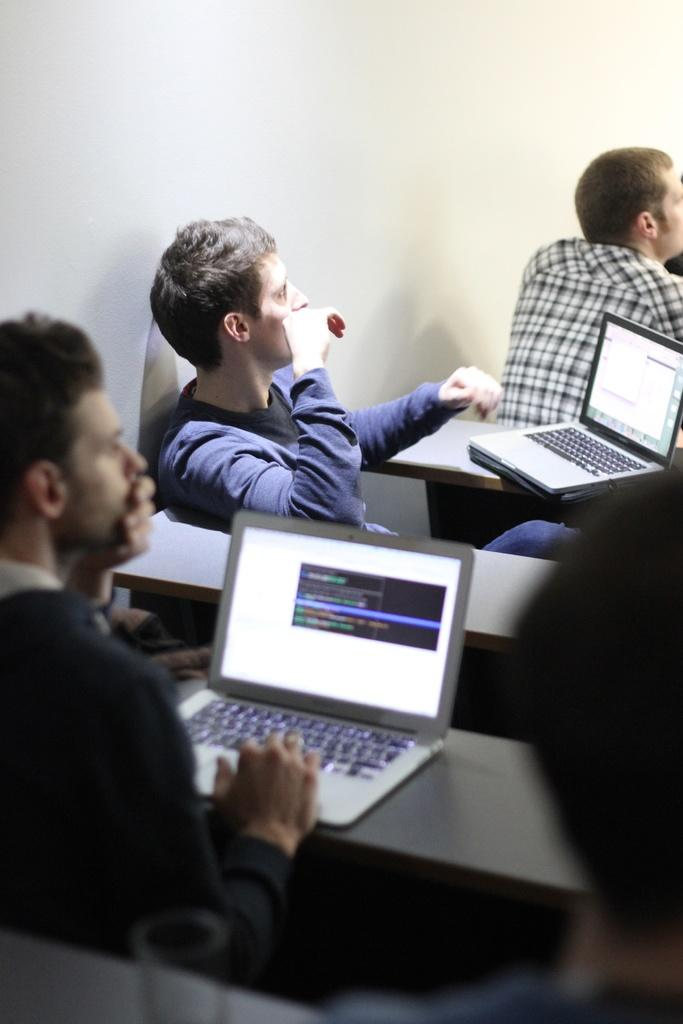What is the main subject of the image? The main subject of the image is a group of men. What are the men doing in the image? The men are sitting together in the image. What is in front of the men? There is a table in front of the men. What objects are on the table? The men have laptops on the table. What might the men be listening to? The men are listening to something in the image. What type of growth can be seen on the queen's crown in the image? There is no queen or crown present in the image; it features a group of men sitting together with laptops on a table. 